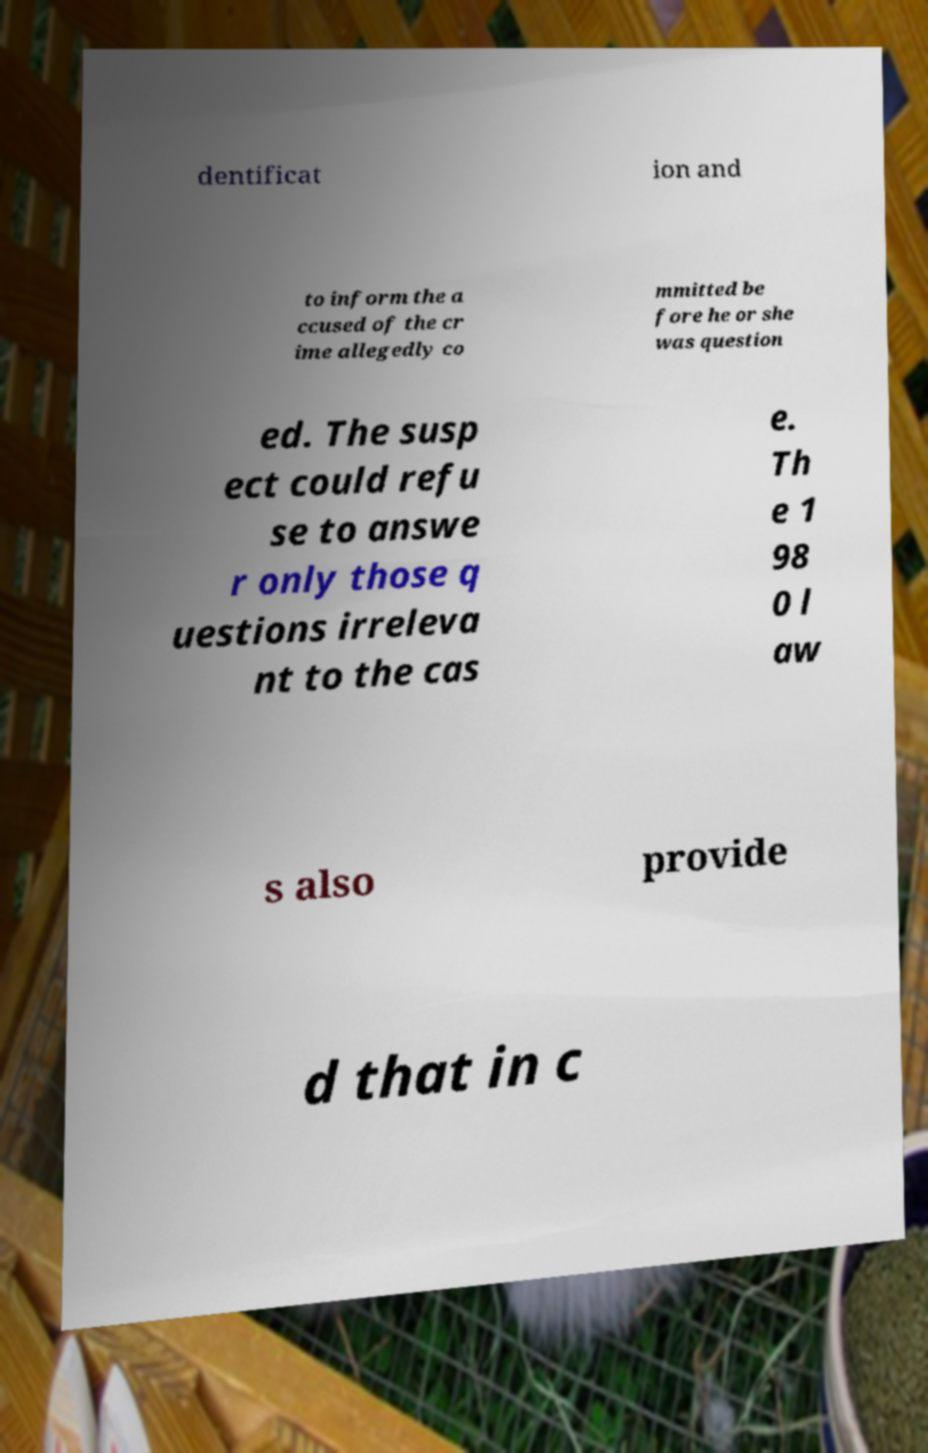Please read and relay the text visible in this image. What does it say? dentificat ion and to inform the a ccused of the cr ime allegedly co mmitted be fore he or she was question ed. The susp ect could refu se to answe r only those q uestions irreleva nt to the cas e. Th e 1 98 0 l aw s also provide d that in c 